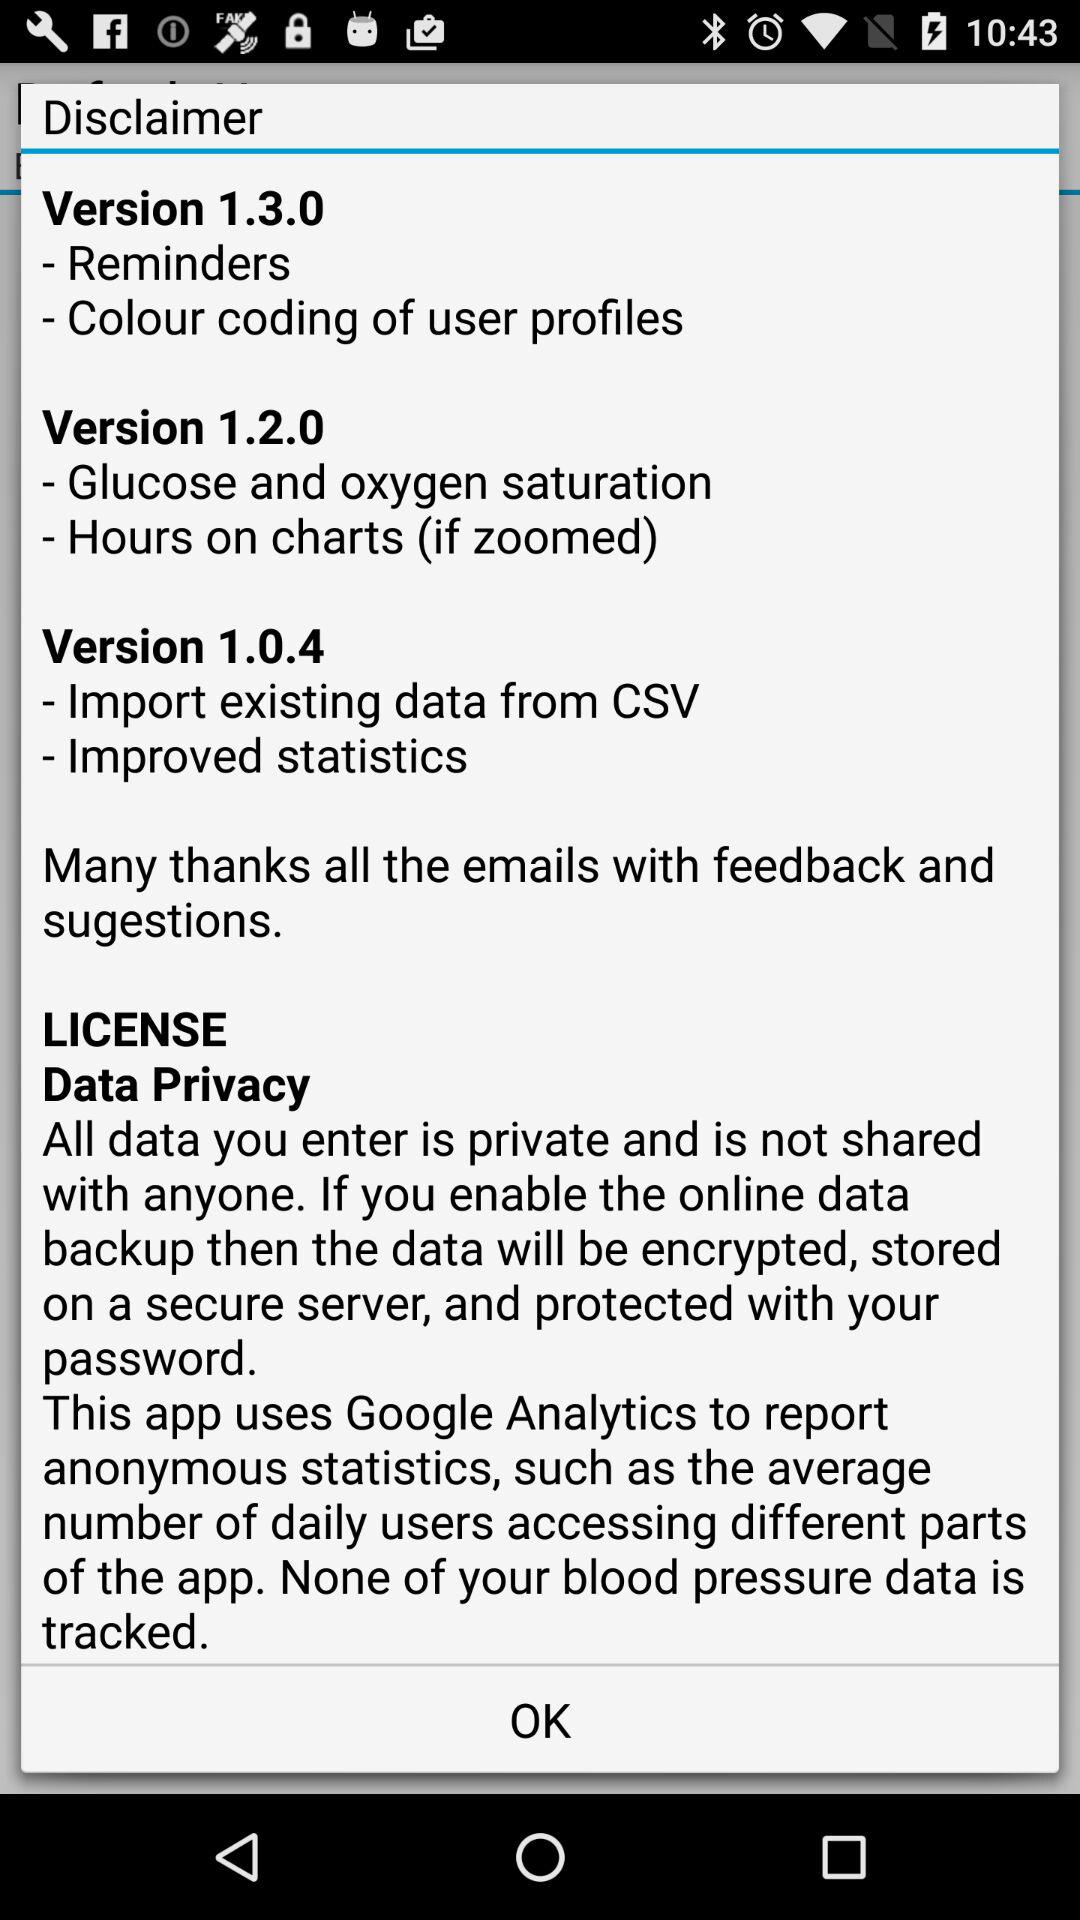What are the points in version 1.0.4? The points in version 1.0.4 are "Import existing data from CSV" and "Improved statistics". 